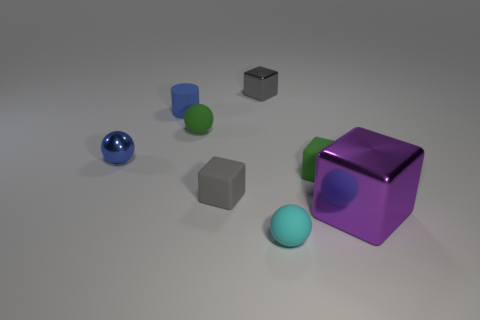Is there any other thing that is the same size as the purple metal object?
Offer a terse response. No. The other shiny thing that is the same shape as the large object is what color?
Offer a terse response. Gray. Are there any other things that are the same shape as the cyan thing?
Your answer should be very brief. Yes. Does the small gray rubber thing that is on the left side of the small gray shiny block have the same shape as the shiny thing that is to the left of the blue rubber cylinder?
Keep it short and to the point. No. Does the matte cylinder have the same size as the green object that is in front of the small blue metallic sphere?
Provide a short and direct response. Yes. Is the number of large purple metal blocks greater than the number of balls?
Provide a short and direct response. No. Do the tiny thing in front of the big shiny block and the green object that is in front of the tiny green ball have the same material?
Offer a very short reply. Yes. What is the material of the big block?
Make the answer very short. Metal. Are there more tiny green things that are behind the cylinder than small matte spheres?
Provide a succinct answer. No. What number of small green rubber things are right of the green rubber object on the right side of the small rubber sphere in front of the tiny gray rubber block?
Offer a very short reply. 0. 